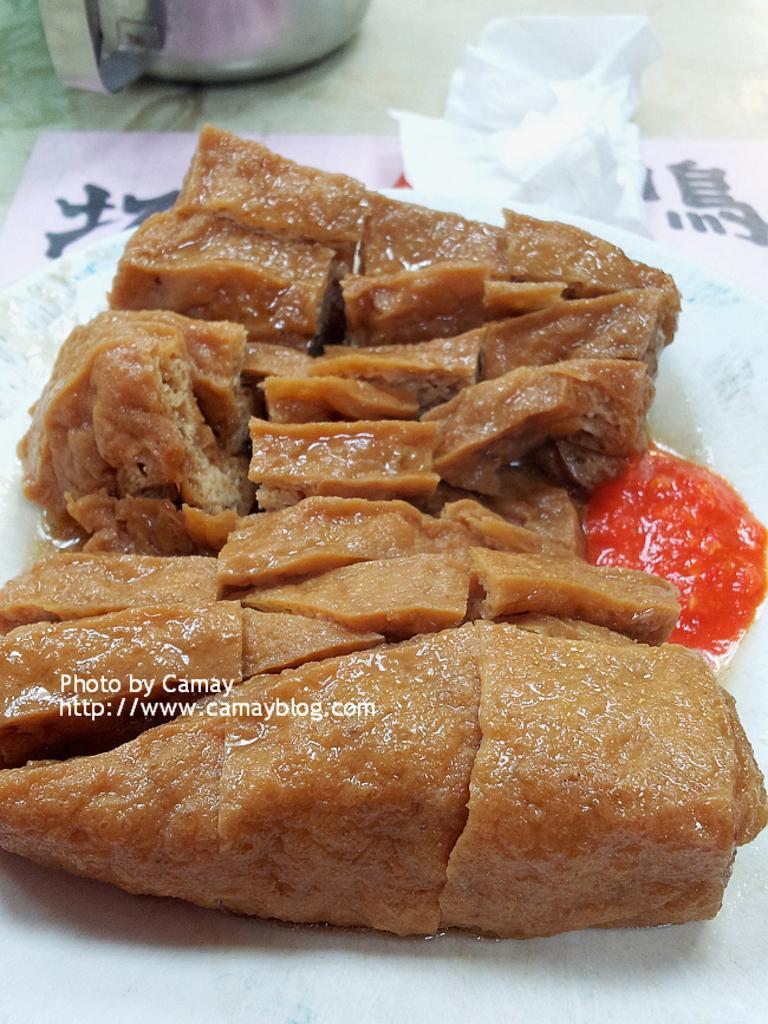Please provide a concise description of this image. In this image there is food on the plate, there is paper on the surface, there is an object truncated towards the top of the image, there is text. 